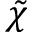<formula> <loc_0><loc_0><loc_500><loc_500>\tilde { \chi }</formula> 